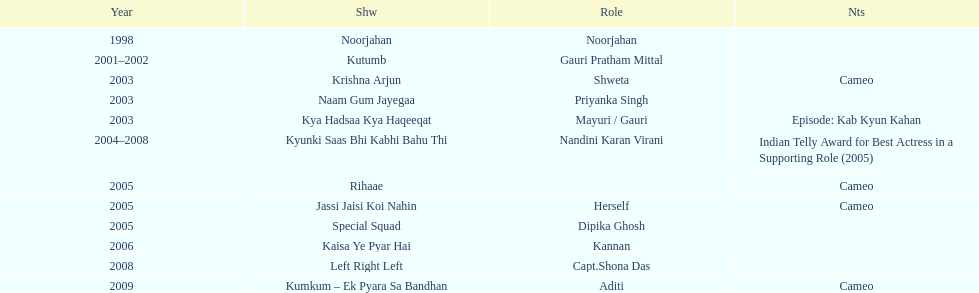How many shows were there in 2005? 3. 